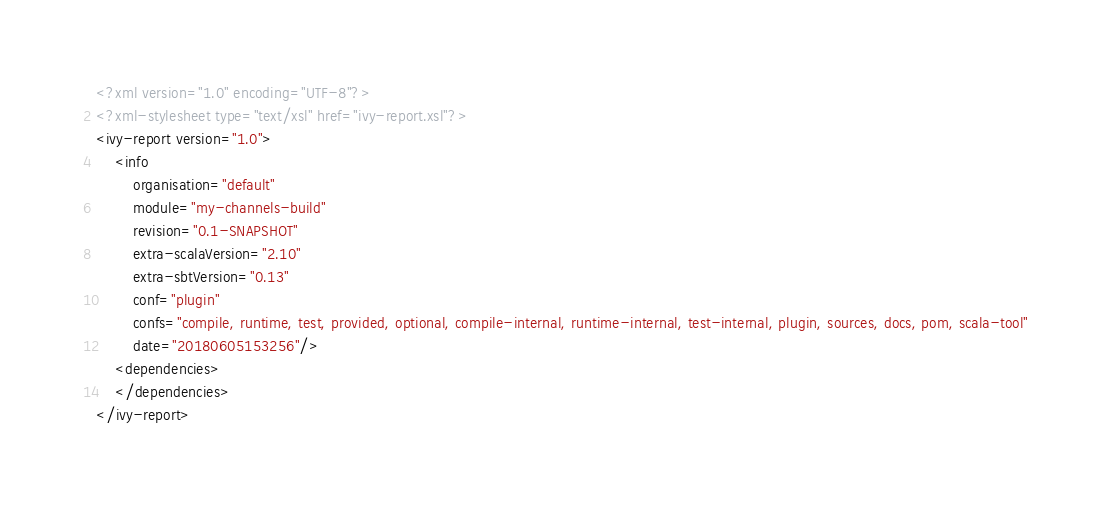Convert code to text. <code><loc_0><loc_0><loc_500><loc_500><_XML_><?xml version="1.0" encoding="UTF-8"?>
<?xml-stylesheet type="text/xsl" href="ivy-report.xsl"?>
<ivy-report version="1.0">
	<info
		organisation="default"
		module="my-channels-build"
		revision="0.1-SNAPSHOT"
		extra-scalaVersion="2.10"
		extra-sbtVersion="0.13"
		conf="plugin"
		confs="compile, runtime, test, provided, optional, compile-internal, runtime-internal, test-internal, plugin, sources, docs, pom, scala-tool"
		date="20180605153256"/>
	<dependencies>
	</dependencies>
</ivy-report>
</code> 